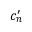<formula> <loc_0><loc_0><loc_500><loc_500>c _ { n } ^ { \prime }</formula> 